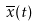Convert formula to latex. <formula><loc_0><loc_0><loc_500><loc_500>\overline { x } ( t )</formula> 